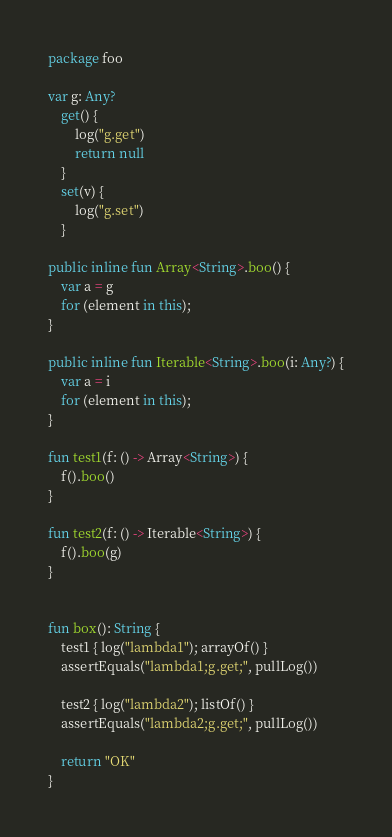<code> <loc_0><loc_0><loc_500><loc_500><_Kotlin_>package foo

var g: Any?
    get() {
        log("g.get")
        return null
    }
    set(v) {
        log("g.set")
    }

public inline fun Array<String>.boo() {
    var a = g
    for (element in this);
}

public inline fun Iterable<String>.boo(i: Any?) {
    var a = i
    for (element in this);
}

fun test1(f: () -> Array<String>) {
    f().boo()
}

fun test2(f: () -> Iterable<String>) {
    f().boo(g)
}


fun box(): String {
    test1 { log("lambda1"); arrayOf() }
    assertEquals("lambda1;g.get;", pullLog())

    test2 { log("lambda2"); listOf() }
    assertEquals("lambda2;g.get;", pullLog())

    return "OK"
}</code> 